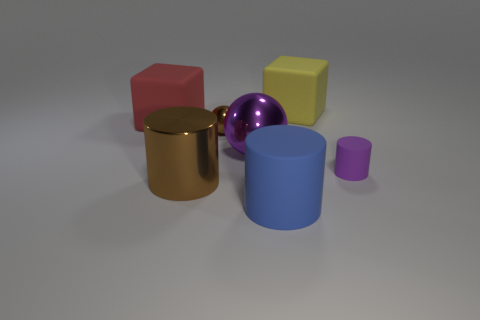How many objects are either red things or large blue shiny blocks?
Your response must be concise. 1. Are there any purple cylinders that have the same material as the tiny purple thing?
Keep it short and to the point. No. There is a metallic cylinder that is the same color as the small ball; what is its size?
Provide a succinct answer. Large. The object that is to the right of the large matte cube on the right side of the large red matte thing is what color?
Your response must be concise. Purple. Is the red block the same size as the blue matte cylinder?
Provide a short and direct response. Yes. How many balls are small brown things or tiny gray objects?
Your answer should be compact. 1. There is a big object on the left side of the metal cylinder; how many tiny brown balls are left of it?
Provide a short and direct response. 0. Does the yellow object have the same shape as the big purple metal object?
Make the answer very short. No. The other brown thing that is the same shape as the small rubber thing is what size?
Provide a short and direct response. Large. What shape is the purple object left of the matte cylinder behind the blue matte cylinder?
Your answer should be very brief. Sphere. 